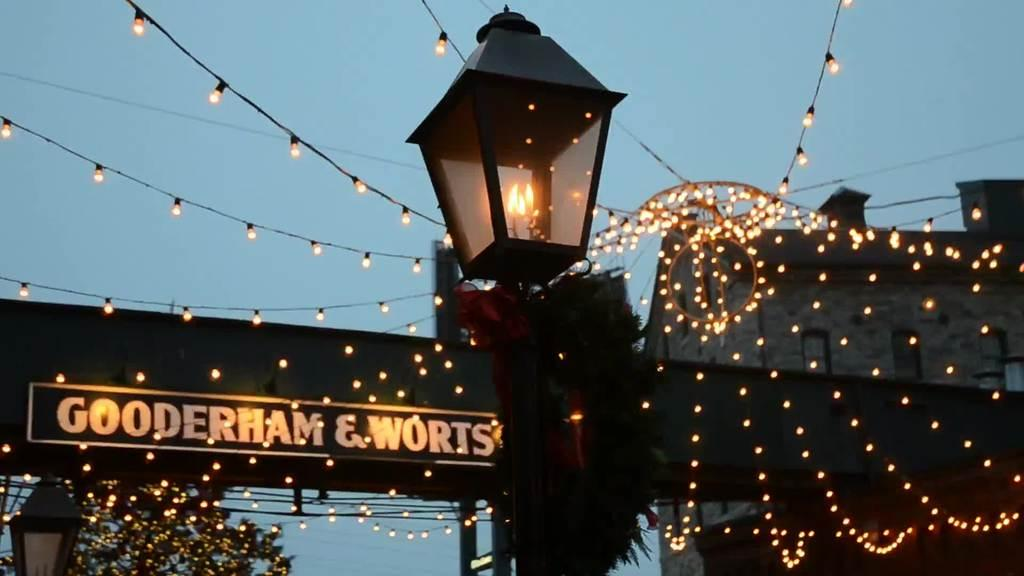What type of light can be seen in the image? There is a pole light in the image. What other type of lighting is present in the image? There are serial lights in the image. What structure is visible in the image? There is a building in the image. What natural element is present in the image? There is a tree in the image. What is the color of the sky in the image? The sky is blue in the image. What is the theory behind the existence of the rail in the image? There is no rail present in the image, so the question of a theory behind its existence is not applicable. 